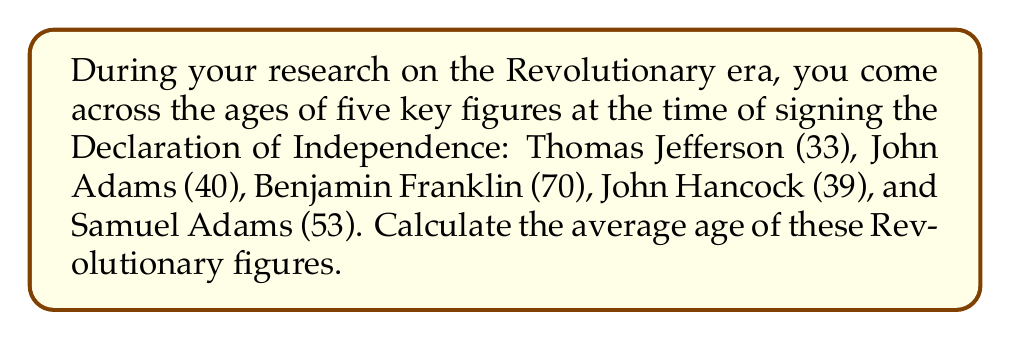Solve this math problem. To find the average age, we need to follow these steps:

1. Sum up all the ages:
   $33 + 40 + 70 + 39 + 53 = 235$

2. Count the total number of figures:
   There are 5 Revolutionary figures in this list.

3. Divide the sum by the total number of figures:
   $\text{Average} = \frac{\text{Sum of ages}}{\text{Number of figures}}$

   $\text{Average} = \frac{235}{5}$

4. Perform the division:
   $\text{Average} = 47$

Therefore, the average age of these key Revolutionary figures at the time of signing the Declaration of Independence was 47 years old.
Answer: 47 years 